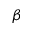<formula> <loc_0><loc_0><loc_500><loc_500>\beta</formula> 